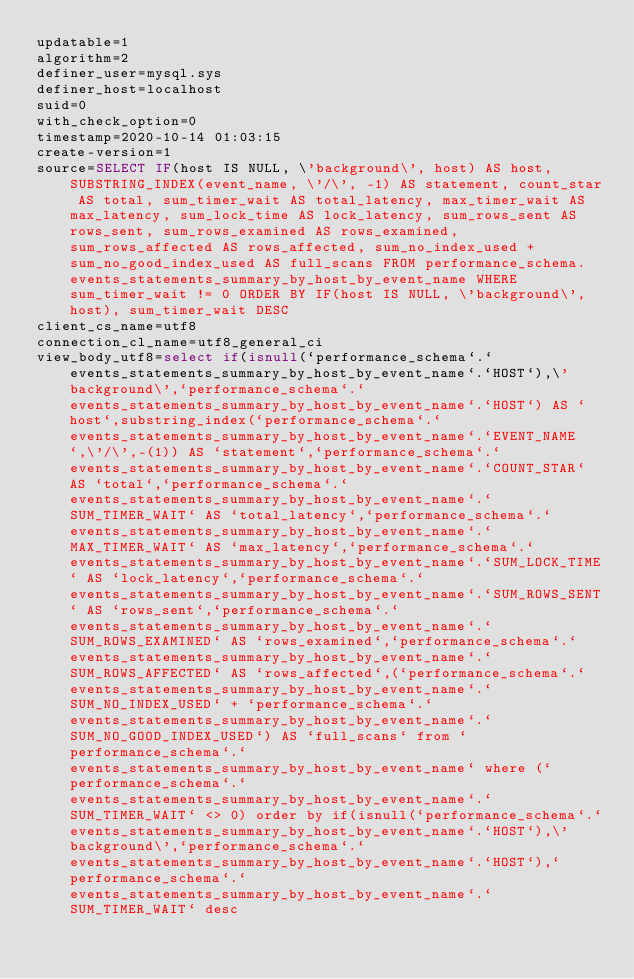<code> <loc_0><loc_0><loc_500><loc_500><_VisualBasic_>updatable=1
algorithm=2
definer_user=mysql.sys
definer_host=localhost
suid=0
with_check_option=0
timestamp=2020-10-14 01:03:15
create-version=1
source=SELECT IF(host IS NULL, \'background\', host) AS host, SUBSTRING_INDEX(event_name, \'/\', -1) AS statement, count_star AS total, sum_timer_wait AS total_latency, max_timer_wait AS max_latency, sum_lock_time AS lock_latency, sum_rows_sent AS rows_sent, sum_rows_examined AS rows_examined, sum_rows_affected AS rows_affected, sum_no_index_used + sum_no_good_index_used AS full_scans FROM performance_schema.events_statements_summary_by_host_by_event_name WHERE sum_timer_wait != 0 ORDER BY IF(host IS NULL, \'background\', host), sum_timer_wait DESC
client_cs_name=utf8
connection_cl_name=utf8_general_ci
view_body_utf8=select if(isnull(`performance_schema`.`events_statements_summary_by_host_by_event_name`.`HOST`),\'background\',`performance_schema`.`events_statements_summary_by_host_by_event_name`.`HOST`) AS `host`,substring_index(`performance_schema`.`events_statements_summary_by_host_by_event_name`.`EVENT_NAME`,\'/\',-(1)) AS `statement`,`performance_schema`.`events_statements_summary_by_host_by_event_name`.`COUNT_STAR` AS `total`,`performance_schema`.`events_statements_summary_by_host_by_event_name`.`SUM_TIMER_WAIT` AS `total_latency`,`performance_schema`.`events_statements_summary_by_host_by_event_name`.`MAX_TIMER_WAIT` AS `max_latency`,`performance_schema`.`events_statements_summary_by_host_by_event_name`.`SUM_LOCK_TIME` AS `lock_latency`,`performance_schema`.`events_statements_summary_by_host_by_event_name`.`SUM_ROWS_SENT` AS `rows_sent`,`performance_schema`.`events_statements_summary_by_host_by_event_name`.`SUM_ROWS_EXAMINED` AS `rows_examined`,`performance_schema`.`events_statements_summary_by_host_by_event_name`.`SUM_ROWS_AFFECTED` AS `rows_affected`,(`performance_schema`.`events_statements_summary_by_host_by_event_name`.`SUM_NO_INDEX_USED` + `performance_schema`.`events_statements_summary_by_host_by_event_name`.`SUM_NO_GOOD_INDEX_USED`) AS `full_scans` from `performance_schema`.`events_statements_summary_by_host_by_event_name` where (`performance_schema`.`events_statements_summary_by_host_by_event_name`.`SUM_TIMER_WAIT` <> 0) order by if(isnull(`performance_schema`.`events_statements_summary_by_host_by_event_name`.`HOST`),\'background\',`performance_schema`.`events_statements_summary_by_host_by_event_name`.`HOST`),`performance_schema`.`events_statements_summary_by_host_by_event_name`.`SUM_TIMER_WAIT` desc
</code> 